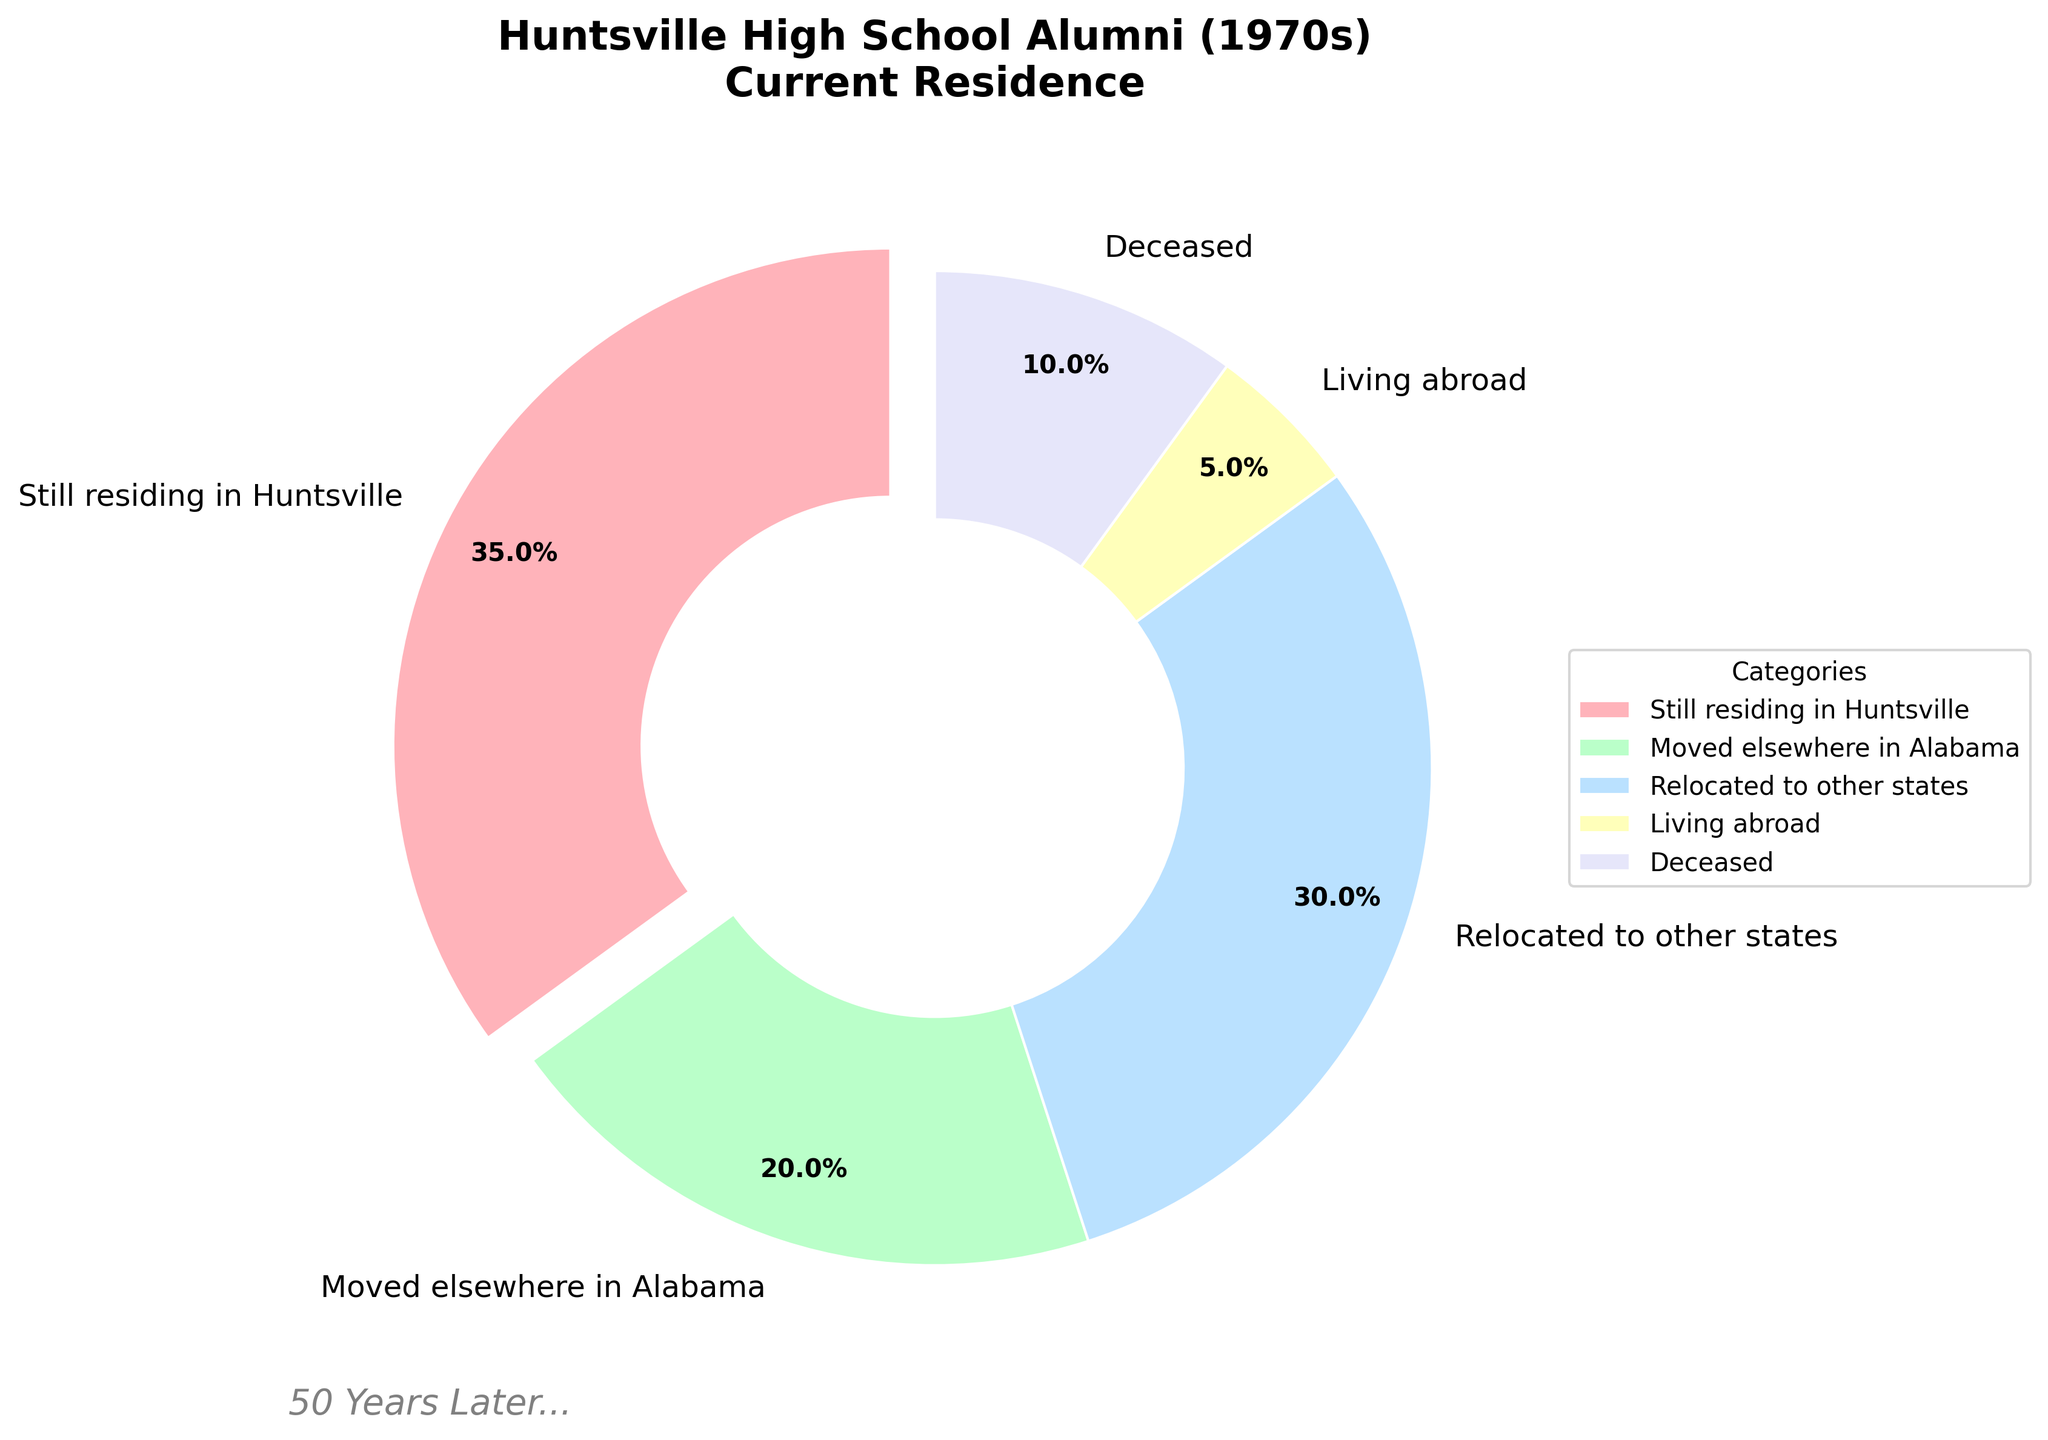What's the total percentage of alumni who have either relocated to other states or are living abroad? Add the percentages for "Relocated to other states (30%)" and "Living abroad (5%)". So, 30% + 5% = 35%.
Answer: 35% Which category has the highest percentage of alumni? Compare the percentages for all categories and see that the "Still residing in Huntsville" category has the highest percentage at 35%.
Answer: Still residing in Huntsville What is the combined percentage of alumni who are either still residing in Huntsville or have moved elsewhere in Alabama? Add the percentages for "Still residing in Huntsville (35%)" and "Moved elsewhere in Alabama (20%)". So, 35% + 20% = 55%.
Answer: 55% How many categories have a percentage lower than 10%? Check the percentages of all categories. Only "Living abroad (5%)" and "Deceased (10%)" are lower than 10%.
Answer: 1 Which section of the pie chart is exploded outwards? The "Still residing in Huntsville" section is exploded outwards visually in the chart.
Answer: Still residing in Huntsville Is the percentage of alumni living abroad greater than the percentage of those who are deceased? Compare the percentages of "Living abroad (5%)" and "Deceased (10%)". The percentage of alumni living abroad is not greater than those who are deceased.
Answer: No What percentage of alumni is either deceased or has moved elsewhere in Alabama? Add the percentages for "Deceased (10%)" and "Moved elsewhere in Alabama (20%)". So, 10% + 20% = 30%.
Answer: 30% What color represents the category 'Moved elsewhere in Alabama'? Identify the color associated with the "Moved elsewhere in Alabama" category, which is green.
Answer: Green Is the percentage of alumni still residing in Huntsville double the percentage of those who are deceased? Compare the percentages: "Still residing in Huntsville (35%)" is more than double the "Deceased (10%)". Double of 10% is 20%, but 35% is greater than 20%.
Answer: Yes How many categories show a two-digit percentage? Check the figure and count the categories with percentages in the two-digit range: "Still residing in Huntsville (35%)", "Moved elsewhere in Alabama (20%)", "Relocated to other states (30%)", and "Deceased (10%)". That's 4 categories.
Answer: 4 